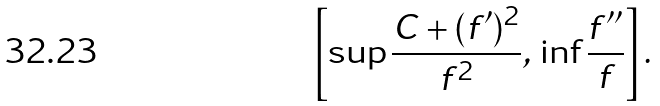Convert formula to latex. <formula><loc_0><loc_0><loc_500><loc_500>\left [ \sup \frac { C + ( f ^ { \prime } ) ^ { 2 } } { f ^ { 2 } } , \, \inf \frac { f ^ { \prime \prime } } { f } \right ] .</formula> 